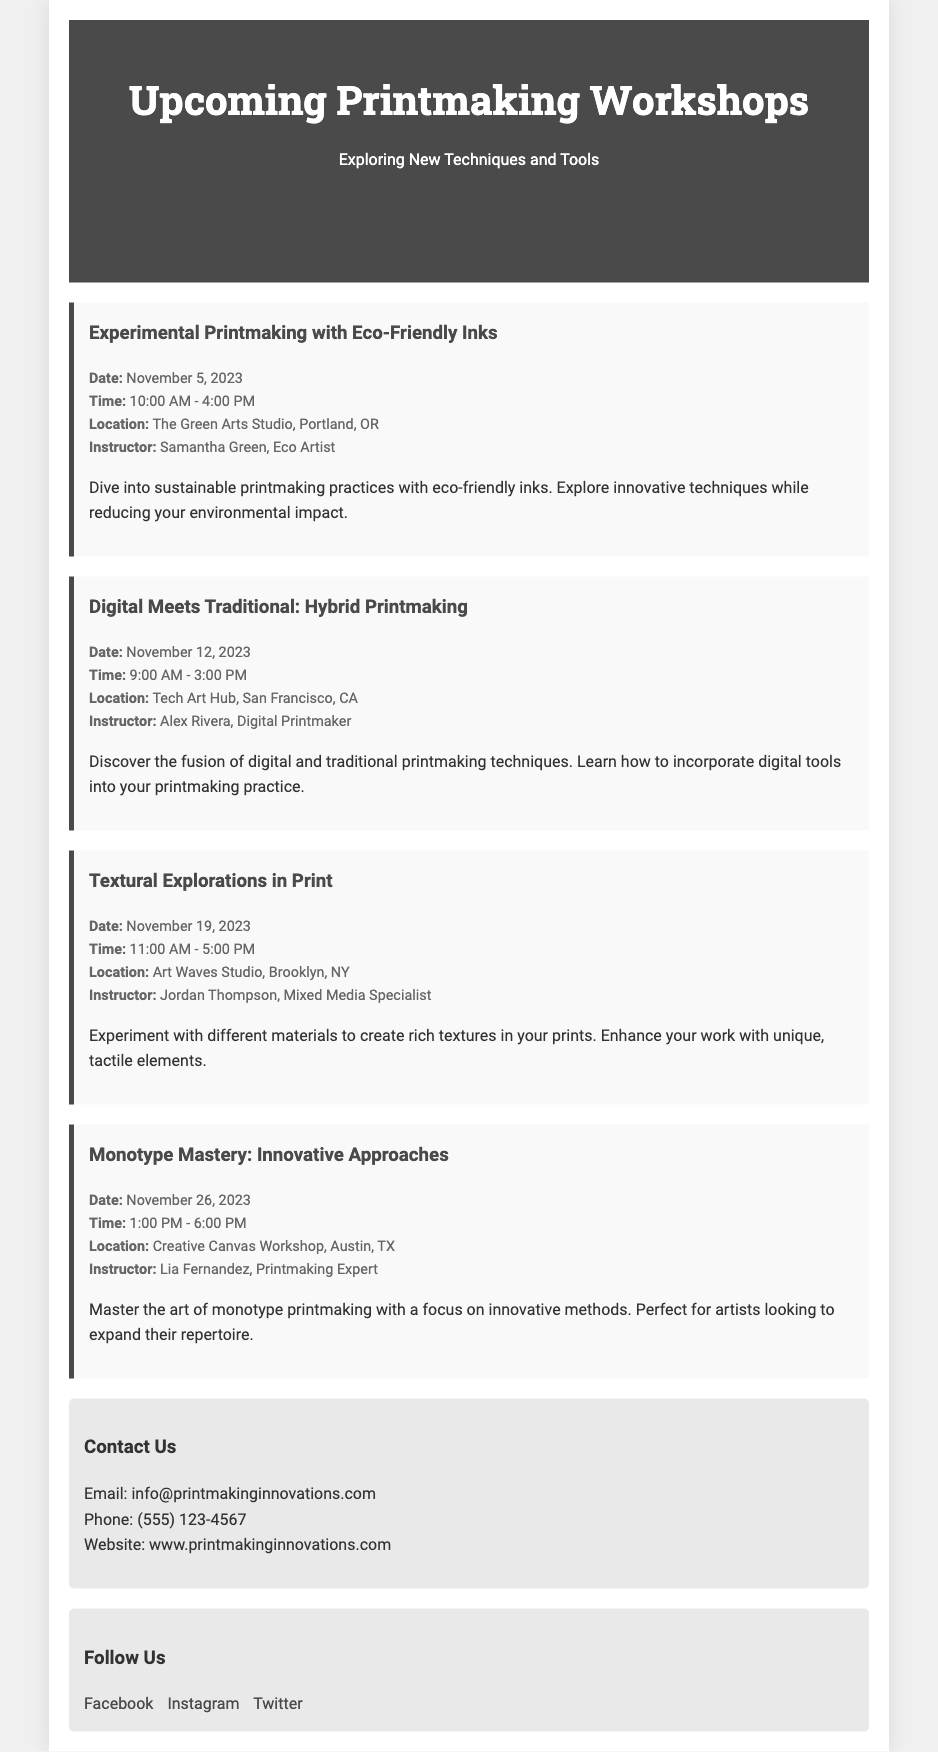What is the title of the flyer? The title of the flyer is the main heading at the top of the document, introducing the workshops.
Answer: Upcoming Printmaking Workshops What is the date for the "Experimental Printmaking with Eco-Friendly Inks" workshop? The date is specified alongside the event details of the first workshop listed.
Answer: November 5, 2023 Who is the instructor for the "Digital Meets Traditional: Hybrid Printmaking" workshop? The instructor's name is provided in the event details for the second workshop.
Answer: Alex Rivera What time does the "Textural Explorations in Print" workshop start? The starting time is mentioned in the event details of the third workshop.
Answer: 11:00 AM Which studio hosts the "Monotype Mastery: Innovative Approaches" workshop? The hosting studio is indicated in the location detail of the fourth workshop.
Answer: Creative Canvas Workshop How many workshops are listed in the document? The total number of workshops can be counted from the individual event sections in the main content.
Answer: Four What type of inks will be used in the "Experimental Printmaking" workshop? The type of inks is described in the short description of the first workshop.
Answer: Eco-Friendly Inks What is the primary focus of the "Monotype Mastery" workshop? The focus is mentioned in the explanation provided alongside the workshop details.
Answer: Innovative Approaches 